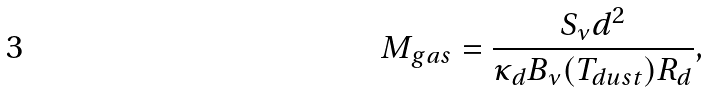<formula> <loc_0><loc_0><loc_500><loc_500>M _ { g a s } = \frac { S _ { \nu } d ^ { 2 } } { { \kappa _ { d } } B _ { \nu } ( T _ { d u s t } ) R _ { d } } ,</formula> 